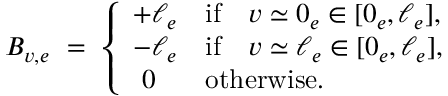<formula> <loc_0><loc_0><loc_500><loc_500>\begin{array} { r } { B _ { v , e } \ = \ \left \{ \begin{array} { l l } { + \ell _ { e } } & { i f \quad v \simeq 0 _ { e } \in [ 0 _ { e } , \ell _ { e } ] , } \\ { - \ell _ { e } } & { i f \quad v \simeq \ell _ { e } \in [ 0 _ { e } , \ell _ { e } ] , } \\ { \ 0 } & { o t h e r w i s e . } \end{array} } \end{array}</formula> 